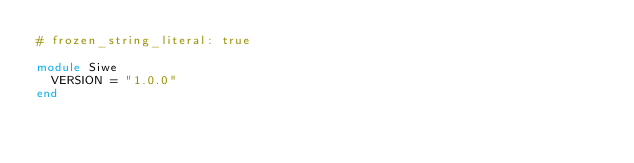<code> <loc_0><loc_0><loc_500><loc_500><_Ruby_># frozen_string_literal: true

module Siwe
  VERSION = "1.0.0"
end
</code> 